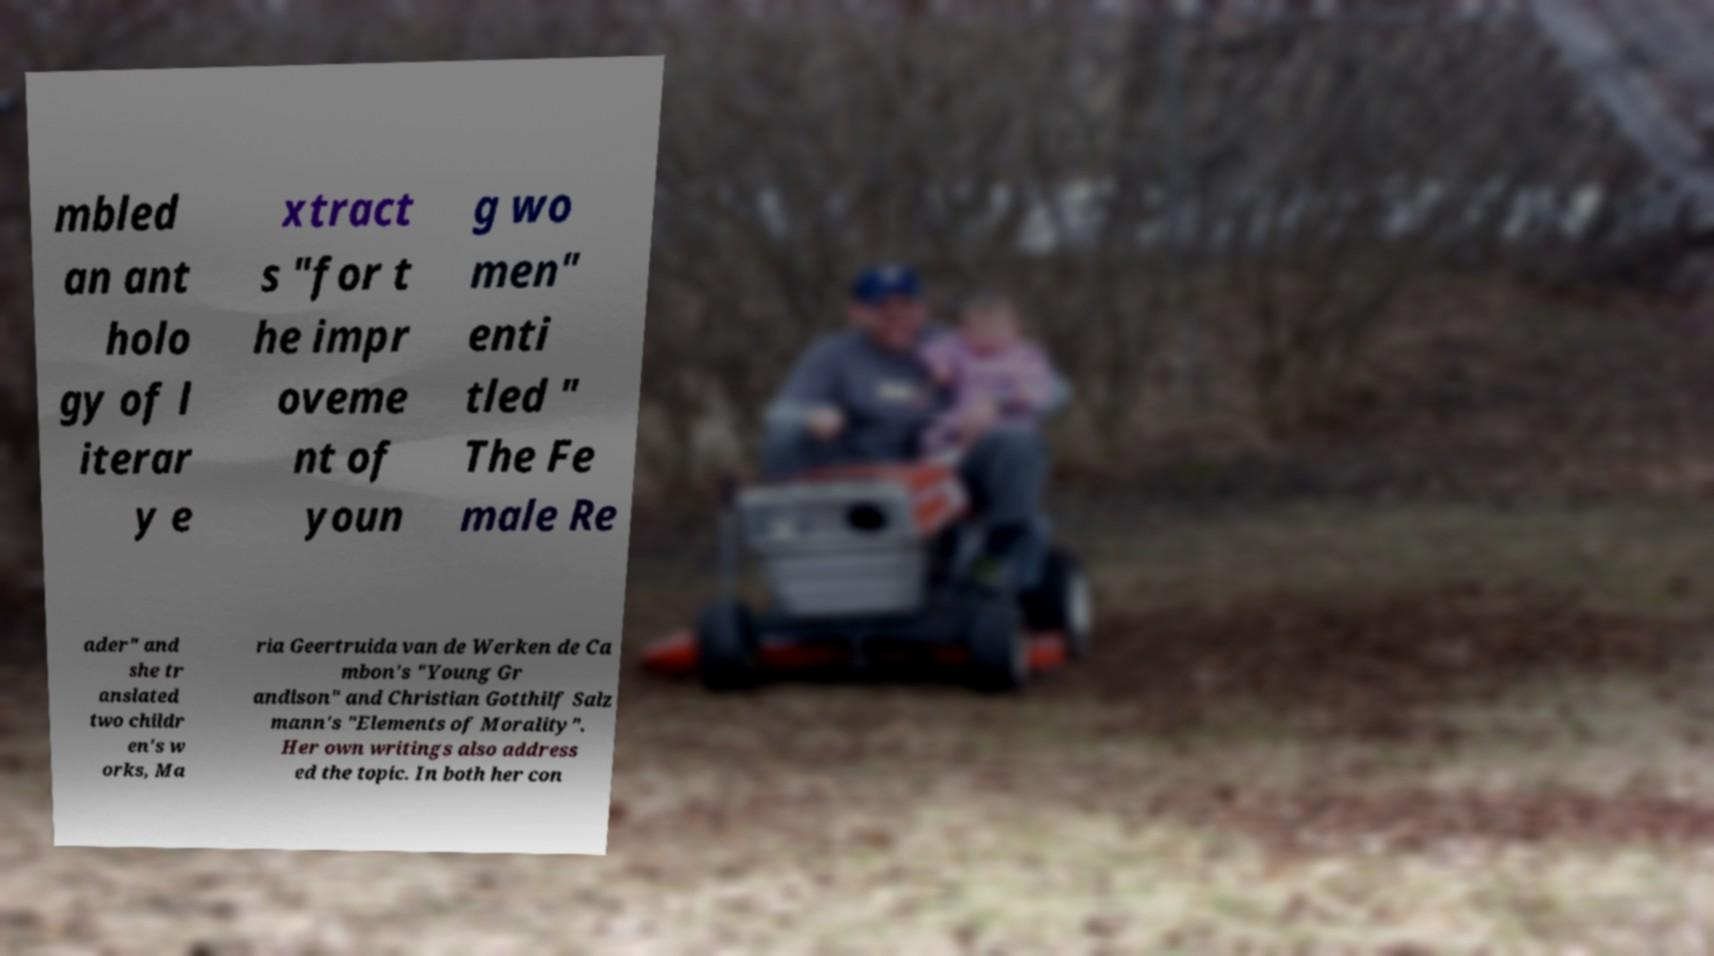I need the written content from this picture converted into text. Can you do that? mbled an ant holo gy of l iterar y e xtract s "for t he impr oveme nt of youn g wo men" enti tled " The Fe male Re ader" and she tr anslated two childr en's w orks, Ma ria Geertruida van de Werken de Ca mbon's "Young Gr andison" and Christian Gotthilf Salz mann's "Elements of Morality". Her own writings also address ed the topic. In both her con 